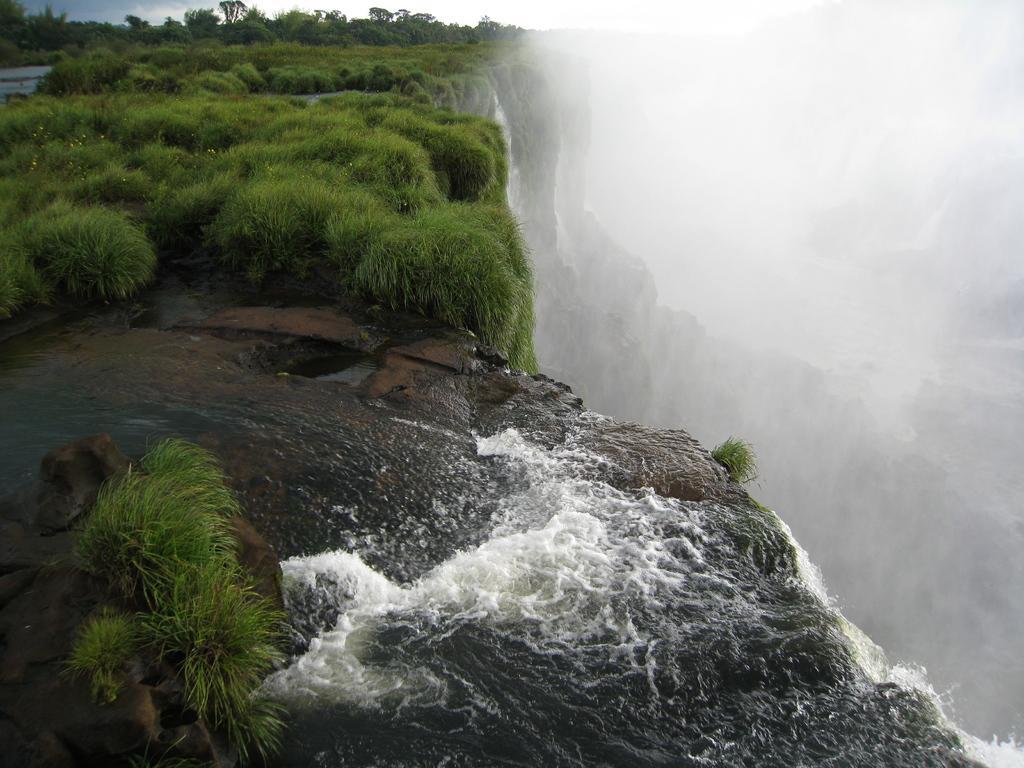Could you give a brief overview of what you see in this image? In the foreground of this image, there are rocks, grass and water. On the right, there is water fall from a cliff. At the top, we can also see grass on the cliff and the sky. 